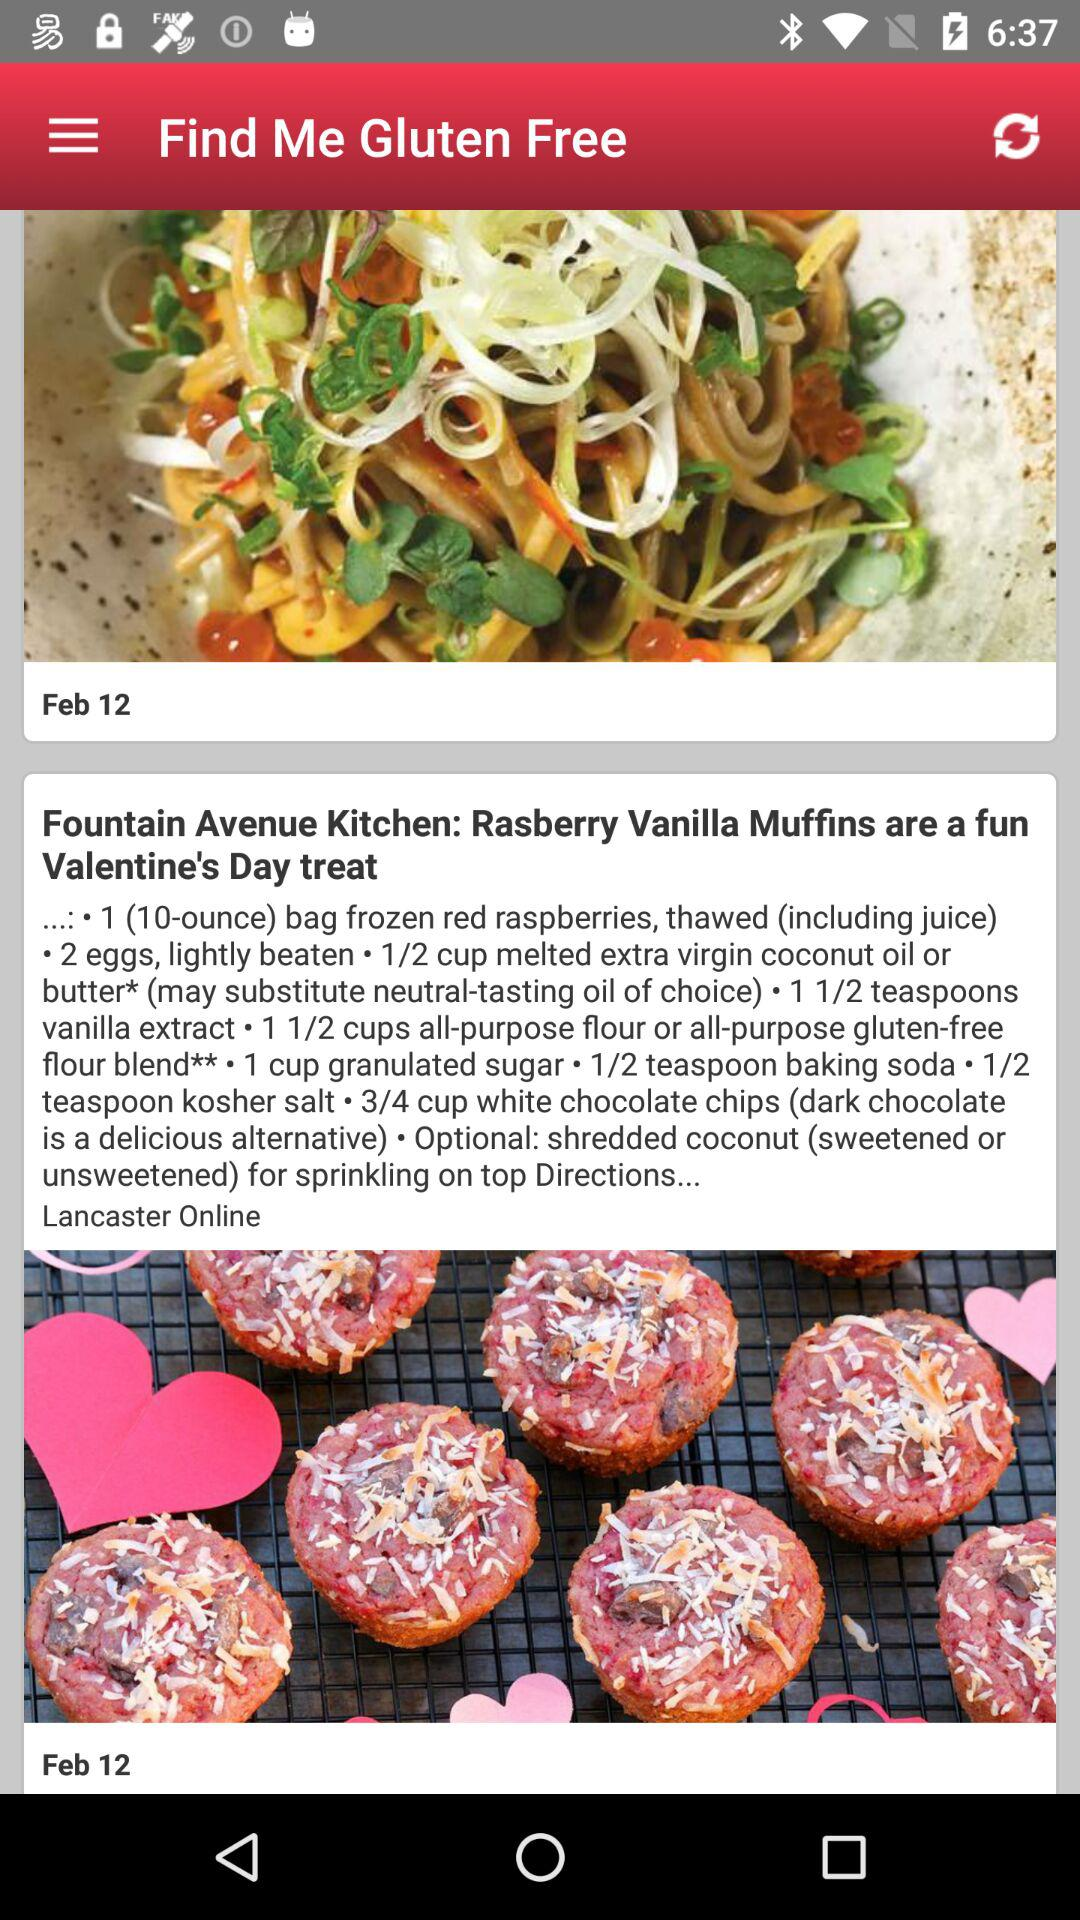How many cups of granulated sugar are needed for the dish? There is 1 cup of granulated sugar needed for the dish. 